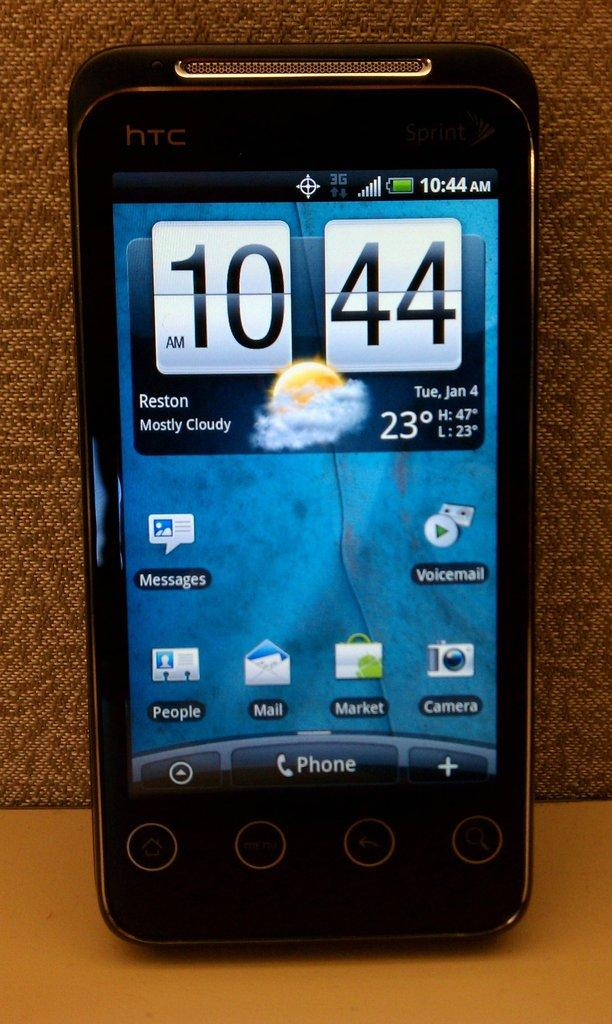Provide a one-sentence caption for the provided image. A cell phone displays the time 10:44 AM and a weather forecast of mostly cloudy. 